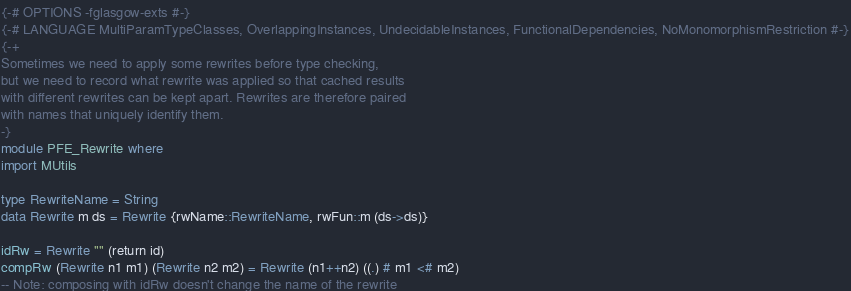Convert code to text. <code><loc_0><loc_0><loc_500><loc_500><_Haskell_>{-# OPTIONS -fglasgow-exts #-}
{-# LANGUAGE MultiParamTypeClasses, OverlappingInstances, UndecidableInstances, FunctionalDependencies, NoMonomorphismRestriction #-}
{-+
Sometimes we need to apply some rewrites before type checking,
but we need to record what rewrite was applied so that cached results
with different rewrites can be kept apart. Rewrites are therefore paired
with names that uniquely identify them.
-}
module PFE_Rewrite where
import MUtils

type RewriteName = String
data Rewrite m ds = Rewrite {rwName::RewriteName, rwFun::m (ds->ds)}

idRw = Rewrite "" (return id)
compRw (Rewrite n1 m1) (Rewrite n2 m2) = Rewrite (n1++n2) ((.) # m1 <# m2)
-- Note: composing with idRw doesn't change the name of the rewrite

</code> 